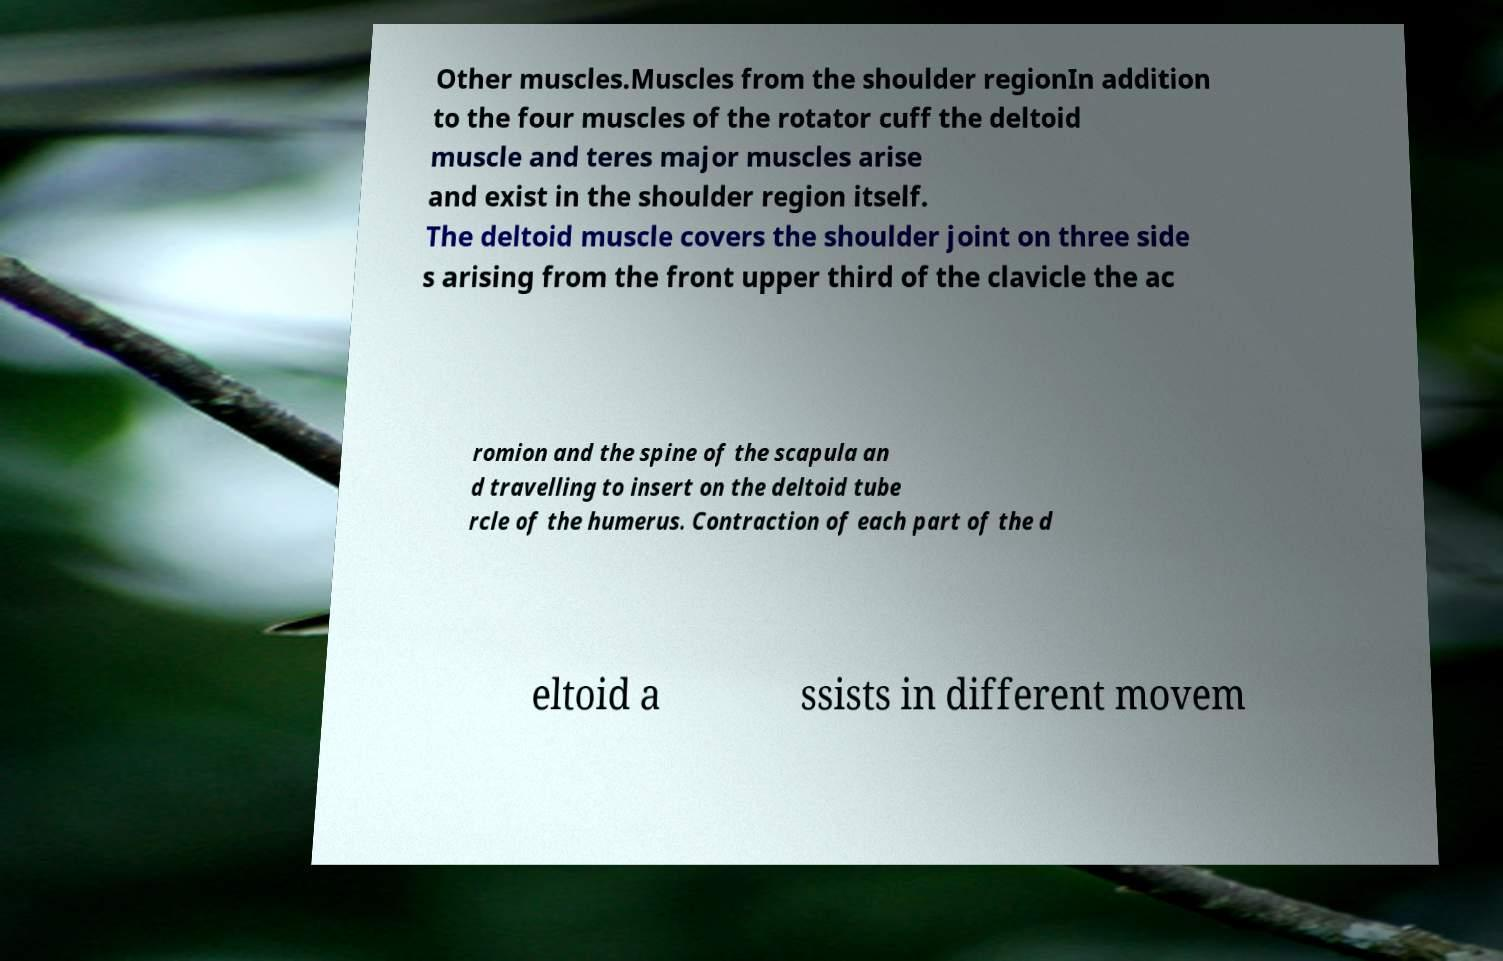I need the written content from this picture converted into text. Can you do that? Other muscles.Muscles from the shoulder regionIn addition to the four muscles of the rotator cuff the deltoid muscle and teres major muscles arise and exist in the shoulder region itself. The deltoid muscle covers the shoulder joint on three side s arising from the front upper third of the clavicle the ac romion and the spine of the scapula an d travelling to insert on the deltoid tube rcle of the humerus. Contraction of each part of the d eltoid a ssists in different movem 